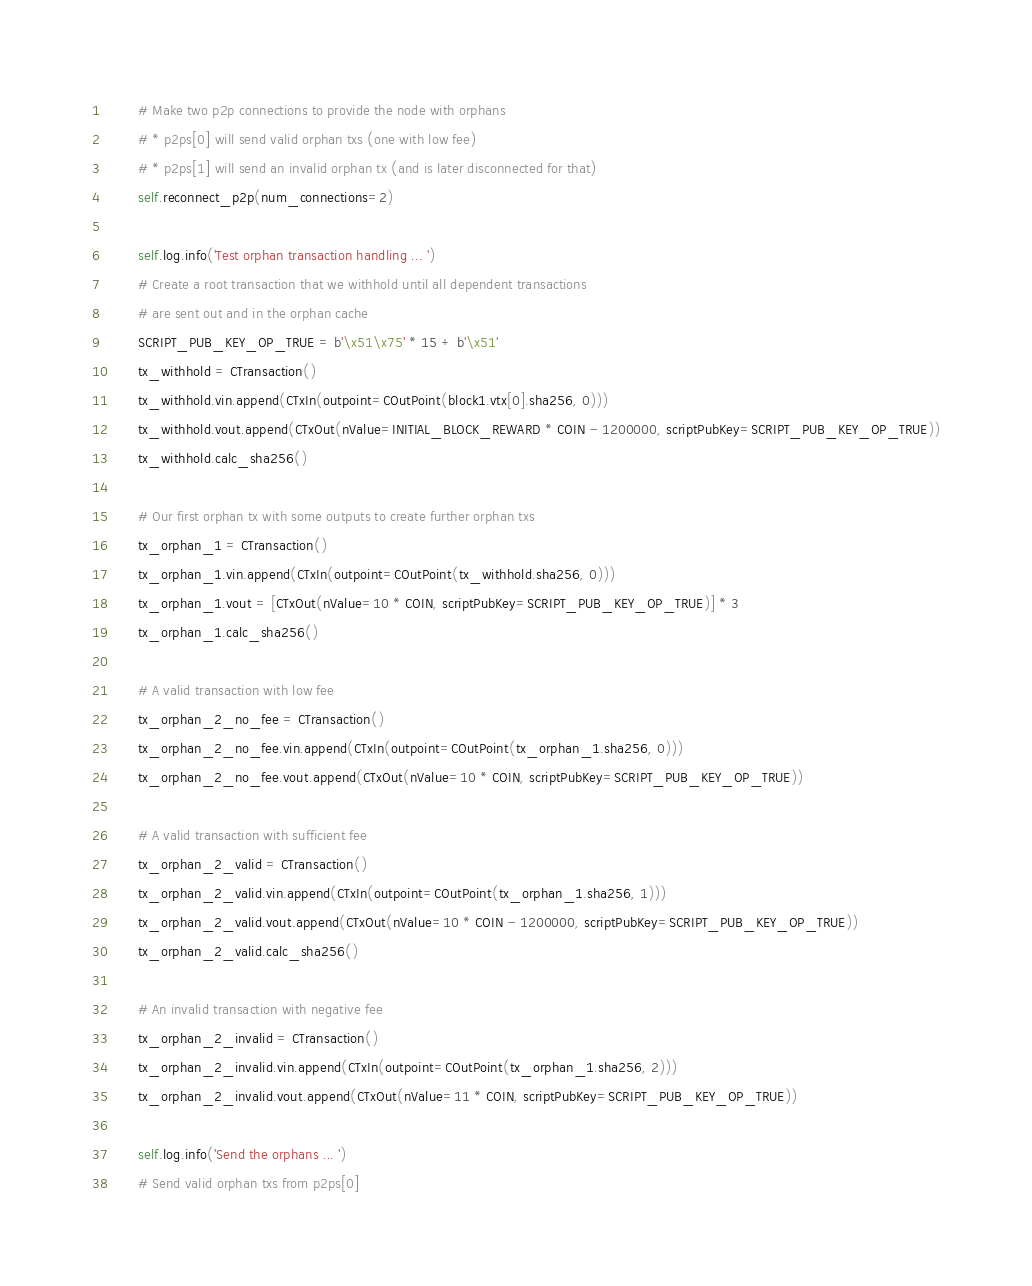Convert code to text. <code><loc_0><loc_0><loc_500><loc_500><_Python_>        # Make two p2p connections to provide the node with orphans
        # * p2ps[0] will send valid orphan txs (one with low fee)
        # * p2ps[1] will send an invalid orphan tx (and is later disconnected for that)
        self.reconnect_p2p(num_connections=2)

        self.log.info('Test orphan transaction handling ... ')
        # Create a root transaction that we withhold until all dependent transactions
        # are sent out and in the orphan cache
        SCRIPT_PUB_KEY_OP_TRUE = b'\x51\x75' * 15 + b'\x51'
        tx_withhold = CTransaction()
        tx_withhold.vin.append(CTxIn(outpoint=COutPoint(block1.vtx[0].sha256, 0)))
        tx_withhold.vout.append(CTxOut(nValue=INITIAL_BLOCK_REWARD * COIN - 1200000, scriptPubKey=SCRIPT_PUB_KEY_OP_TRUE))
        tx_withhold.calc_sha256()

        # Our first orphan tx with some outputs to create further orphan txs
        tx_orphan_1 = CTransaction()
        tx_orphan_1.vin.append(CTxIn(outpoint=COutPoint(tx_withhold.sha256, 0)))
        tx_orphan_1.vout = [CTxOut(nValue=10 * COIN, scriptPubKey=SCRIPT_PUB_KEY_OP_TRUE)] * 3
        tx_orphan_1.calc_sha256()

        # A valid transaction with low fee
        tx_orphan_2_no_fee = CTransaction()
        tx_orphan_2_no_fee.vin.append(CTxIn(outpoint=COutPoint(tx_orphan_1.sha256, 0)))
        tx_orphan_2_no_fee.vout.append(CTxOut(nValue=10 * COIN, scriptPubKey=SCRIPT_PUB_KEY_OP_TRUE))

        # A valid transaction with sufficient fee
        tx_orphan_2_valid = CTransaction()
        tx_orphan_2_valid.vin.append(CTxIn(outpoint=COutPoint(tx_orphan_1.sha256, 1)))
        tx_orphan_2_valid.vout.append(CTxOut(nValue=10 * COIN - 1200000, scriptPubKey=SCRIPT_PUB_KEY_OP_TRUE))
        tx_orphan_2_valid.calc_sha256()

        # An invalid transaction with negative fee
        tx_orphan_2_invalid = CTransaction()
        tx_orphan_2_invalid.vin.append(CTxIn(outpoint=COutPoint(tx_orphan_1.sha256, 2)))
        tx_orphan_2_invalid.vout.append(CTxOut(nValue=11 * COIN, scriptPubKey=SCRIPT_PUB_KEY_OP_TRUE))

        self.log.info('Send the orphans ... ')
        # Send valid orphan txs from p2ps[0]</code> 